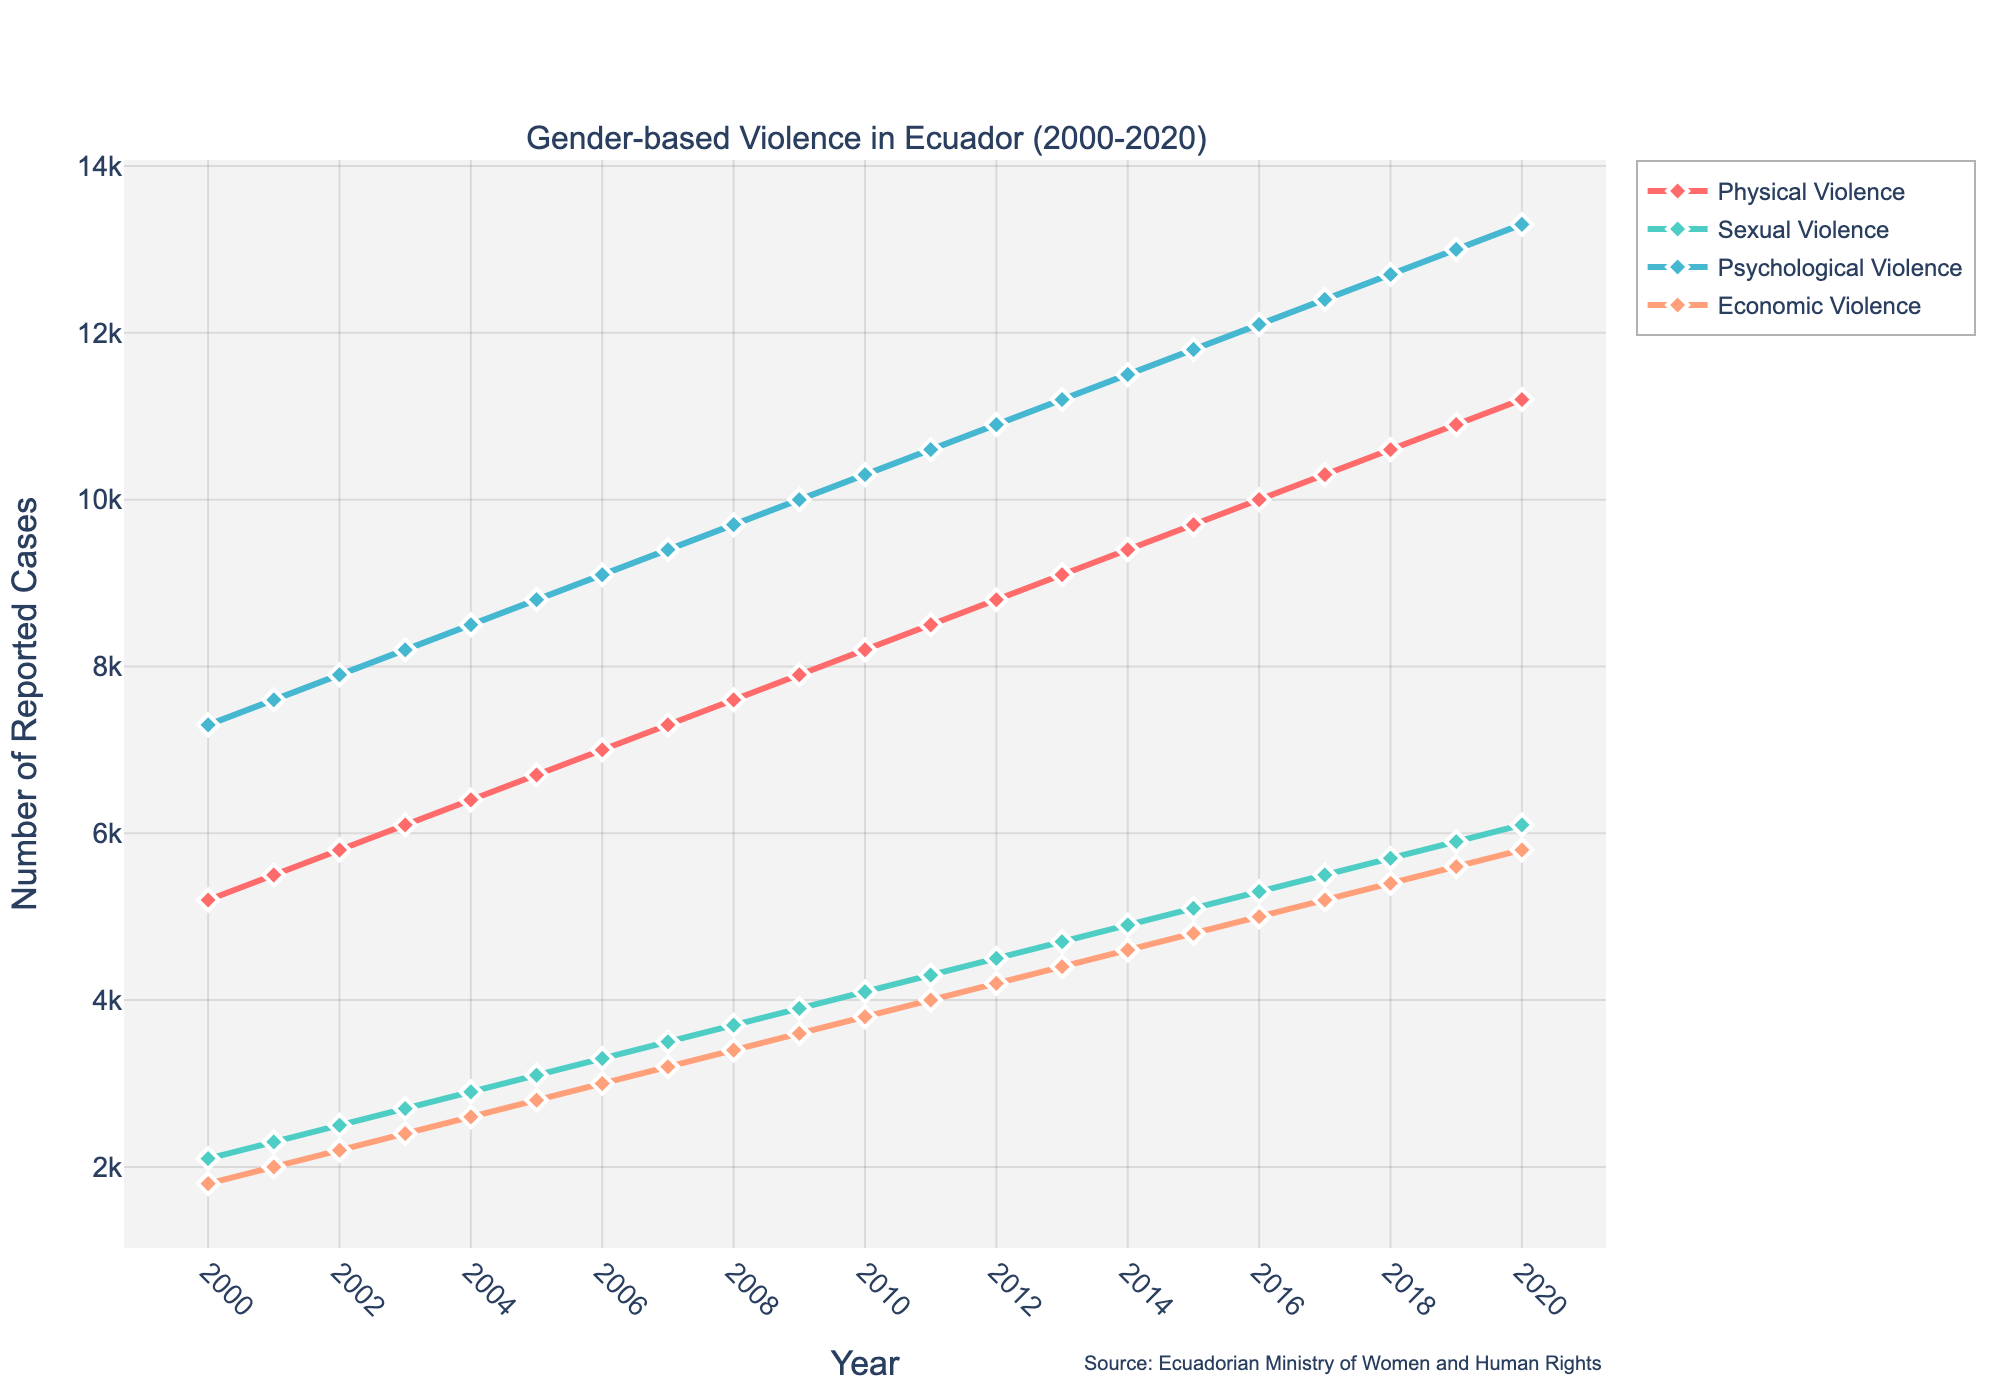What type of violence had the highest number of reported cases in 2020? Psychological Violence had 13,300 reported cases in 2020, which is higher than any other type shown in the figure.
Answer: Psychological Violence How did the number of reported cases of Sexual Violence change from 2000 to 2020? To get the difference, subtract the number of reported cases in 2000 from those in 2020: 6100 (2020) - 2100 (2000) = 4000. Therefore, there was an increase of 4000 reported cases.
Answer: Increased by 4000 Which type of violence showed the most consistent increase in reported cases over the years? We observe the lines representing different types of violence. The line for Psychological Violence shows a steady and consistent increase from 2000 to 2020 without any abrupt changes.
Answer: Psychological Violence What is the total number of reported cases for Physical Violence over the two decades? Sum the number of reported Physical Violence cases from 2000 to 2020: 5200 + 5500 + 5800 + 6100 + 6400 + 6700 + 7000 + 7300 + 7600 + 7900 + 8200 + 8500 + 8800 + 9100 + 9400 + 9700 + 10000 + 10300 + 10600 + 10900 + 11200 = 171700
Answer: 171700 In which year did Economic Violence surpass 4000 reported cases? Looking at the trendline, Economic Violence surpassed 4000 reported cases in the year 2011.
Answer: 2011 Which type of violence had the smallest increase in reported cases from 2000 to 2020? Subtract the values of each type of violence in 2000 from their respective values in 2020:
- Physical: 11200 - 5200 = 6000
- Sexual: 6100 - 2100 = 4000
- Psychological: 13300 - 7300 = 6000
- Economic: 5800 - 1800 = 4000
Both Sexual and Economic Violences show a 4000 increase, which is the smallest.
Answer: Sexual and Economic Violence What is the average number of reported cases of Psychological Violence over the two decades? Calculate the average by summing up all the reported cases from 2000 to 2020 and then dividing by the number of years:
(7300 + 7600 + 7900 + 8200 + 8500 + 8800 + 9100 + 9400 + 9700 + 10000 + 10300 + 10600 + 10900 + 11200 + 11500 + 11800 + 12100 + 12400 + 12700 + 13000 + 13300) / 21 = 10238.1
Answer: 10238.1 Which year had the highest total number of reported cases across all types of violence? Sum the reported cases for each type of violence in each year and identify the year with the highest total:
2020: 11200 (Physical) + 6100 (Sexual) + 13300 (Psychological) + 5800 (Economic) = 36400, which is the highest among all years.
Answer: 2020 